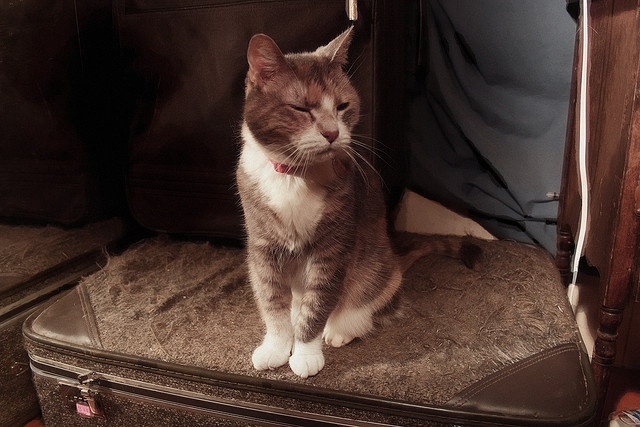Describe the objects in this image and their specific colors. I can see suitcase in black, maroon, and brown tones, cat in black, maroon, gray, and brown tones, and suitcase in black, maroon, and gray tones in this image. 